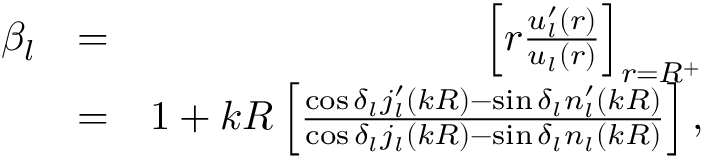<formula> <loc_0><loc_0><loc_500><loc_500>\begin{array} { r l r } { \beta _ { l } } & { = } & { \left [ r \frac { u _ { l } ^ { \prime } ( r ) } { u _ { l } ( r ) } \right ] _ { r = R ^ { + } } } \\ & { = } & { 1 + k R \left [ \frac { \cos \delta _ { l } j _ { l } ^ { \prime } ( k R ) - \sin \delta _ { l } n _ { l } ^ { \prime } ( k R ) } { \cos \delta _ { l } j _ { l } ( k R ) - \sin \delta _ { l } n _ { l } ( k R ) } \right ] , } \end{array}</formula> 